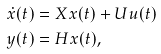<formula> <loc_0><loc_0><loc_500><loc_500>\dot { x } ( t ) & = X x ( t ) + U u ( t ) \\ y ( t ) & = H x ( t ) ,</formula> 